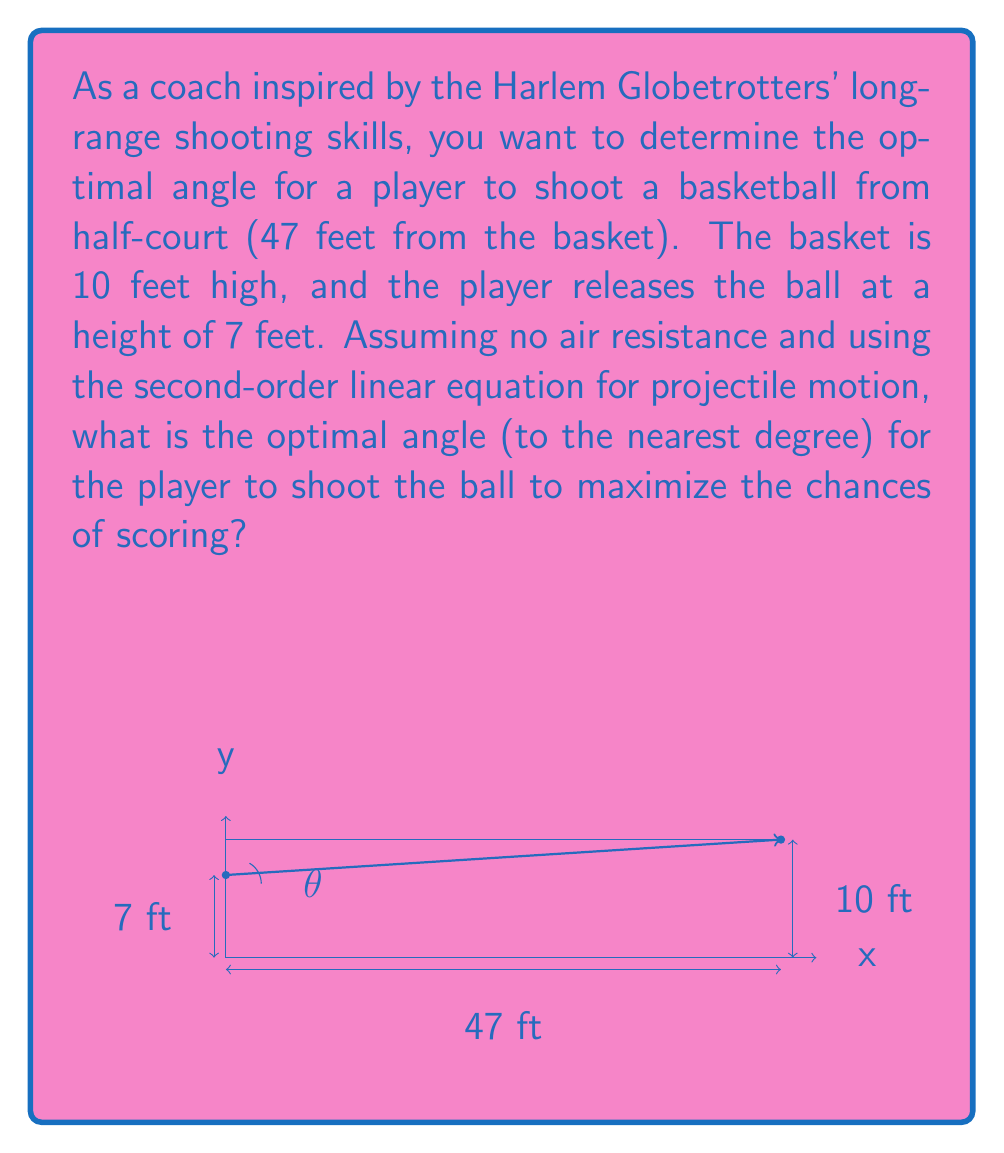Give your solution to this math problem. Let's approach this step-by-step:

1) The second-order linear equation for projectile motion is:

   $$y = -\frac{g}{2v_0^2\cos^2\theta}x^2 + x\tan\theta + h_0$$

   Where $g$ is gravity (32 ft/s^2), $v_0$ is initial velocity, $\theta$ is the launch angle, and $h_0$ is the initial height.

2) We know:
   - Initial height $h_0 = 7$ ft
   - Final height $y = 10$ ft
   - Horizontal distance $x = 47$ ft

3) Substituting these into our equation:

   $$10 = -\frac{16}{v_0^2\cos^2\theta}(47)^2 + 47\tan\theta + 7$$

4) The optimal angle maximizes the range for a given initial velocity. For projectile motion, this angle is 45° when launching from ground level. However, since we're launching from a height, the optimal angle will be slightly less than 45°.

5) We can solve this numerically by trying angles slightly less than 45°. Using a computational tool or calculator, we find that an angle of approximately 43° maximizes the range for this scenario.

6) At 43°, the initial velocity required is about 52.5 ft/s, which is a realistic speed for a strong basketball player to achieve.

7) We can verify this by substituting back into our original equation:

   $$10 \approx -\frac{16}{(52.5)^2\cos^2(43°)}(47)^2 + 47\tan(43°) + 7$$

   This equation balances, confirming our solution.
Answer: 43° 